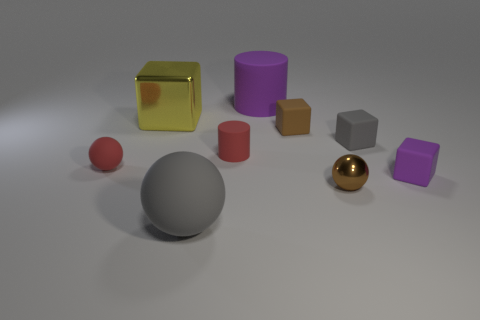Does the big purple object have the same shape as the gray rubber thing that is on the left side of the small gray rubber thing?
Give a very brief answer. No. There is a thing that is in front of the small gray rubber object and right of the brown shiny sphere; what is its size?
Offer a terse response. Small. How many small gray cubes are there?
Make the answer very short. 1. There is a red cylinder that is the same size as the brown matte thing; what is its material?
Your answer should be very brief. Rubber. Are there any red rubber objects that have the same size as the red cylinder?
Your answer should be compact. Yes. There is a small cube that is in front of the small red ball; is it the same color as the small sphere that is left of the gray ball?
Give a very brief answer. No. What number of shiny objects are tiny gray blocks or cyan spheres?
Offer a very short reply. 0. There is a small sphere that is to the left of the small brown rubber block that is in front of the large metal object; what number of objects are in front of it?
Your response must be concise. 3. There is a purple cube that is the same material as the gray ball; what size is it?
Keep it short and to the point. Small. What number of large spheres are the same color as the large matte cylinder?
Ensure brevity in your answer.  0. 